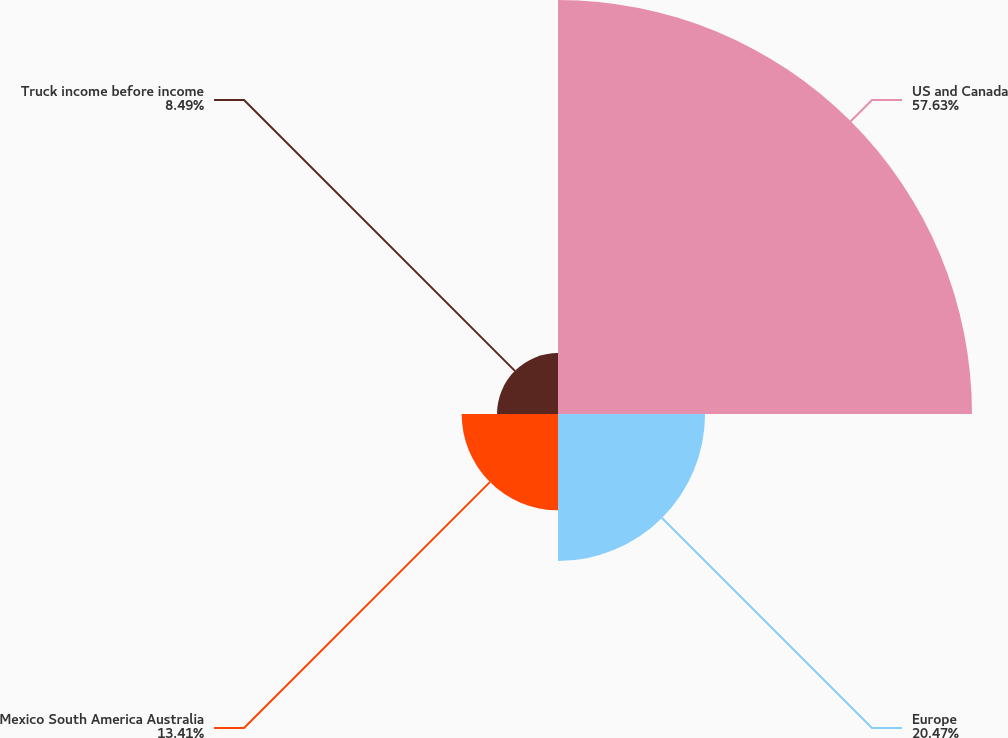Convert chart to OTSL. <chart><loc_0><loc_0><loc_500><loc_500><pie_chart><fcel>US and Canada<fcel>Europe<fcel>Mexico South America Australia<fcel>Truck income before income<nl><fcel>57.63%<fcel>20.47%<fcel>13.41%<fcel>8.49%<nl></chart> 